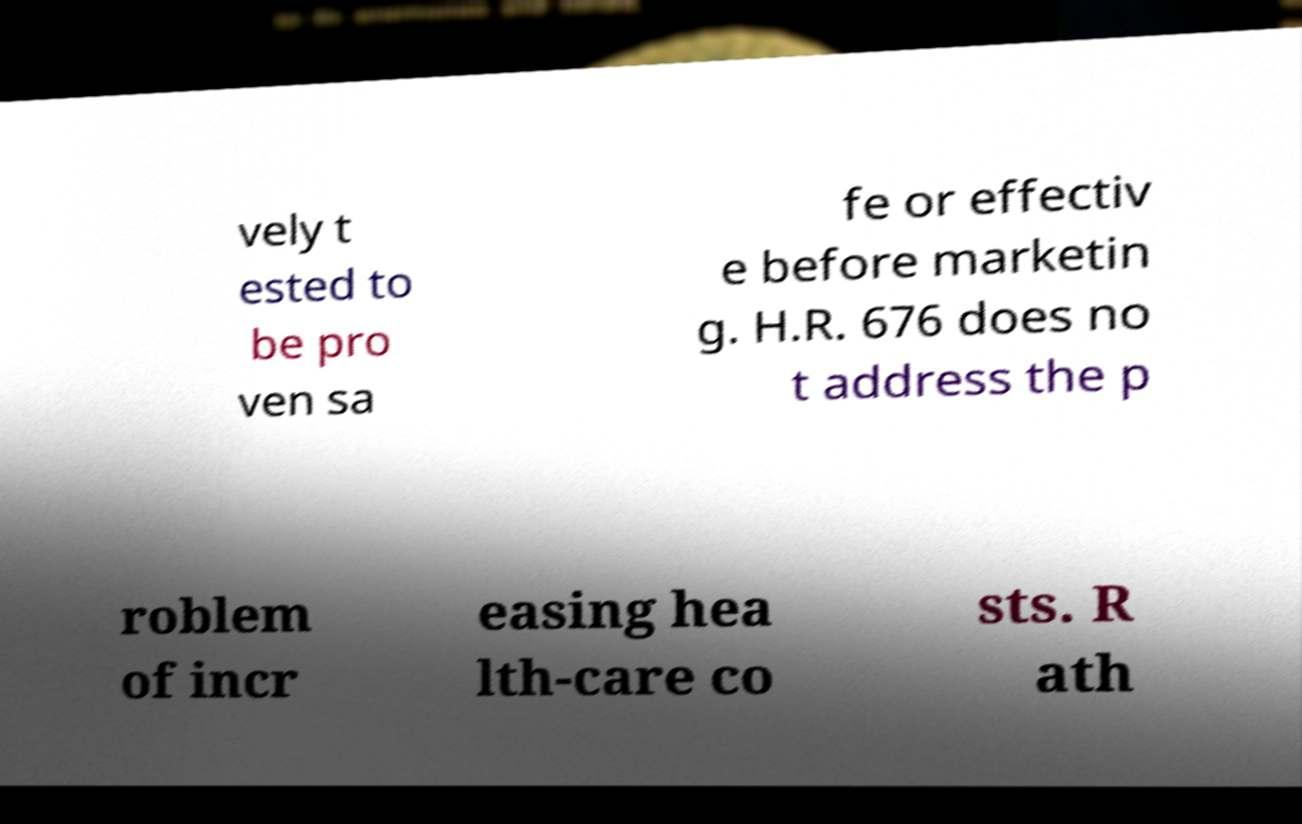There's text embedded in this image that I need extracted. Can you transcribe it verbatim? vely t ested to be pro ven sa fe or effectiv e before marketin g. H.R. 676 does no t address the p roblem of incr easing hea lth-care co sts. R ath 